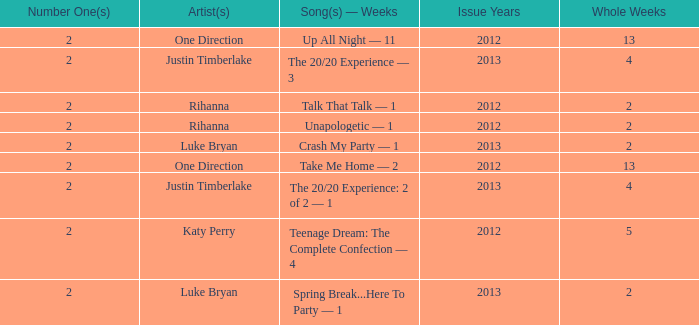What is the title of every song, and how many weeks was each song at #1 for One Direction? Up All Night — 11, Take Me Home — 2. 